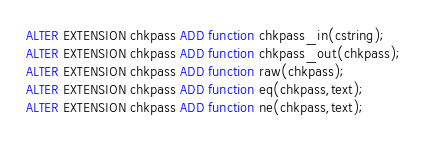<code> <loc_0><loc_0><loc_500><loc_500><_SQL_>ALTER EXTENSION chkpass ADD function chkpass_in(cstring);
ALTER EXTENSION chkpass ADD function chkpass_out(chkpass);
ALTER EXTENSION chkpass ADD function raw(chkpass);
ALTER EXTENSION chkpass ADD function eq(chkpass,text);
ALTER EXTENSION chkpass ADD function ne(chkpass,text);</code> 